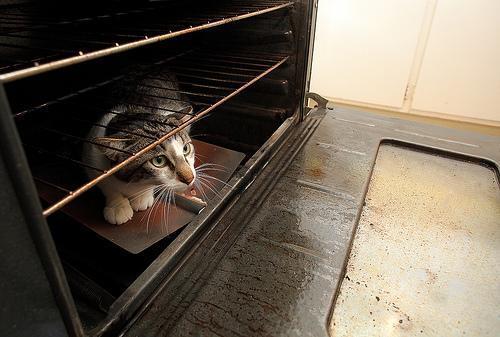How many cats are there?
Give a very brief answer. 1. How many shelf are there?
Give a very brief answer. 2. 